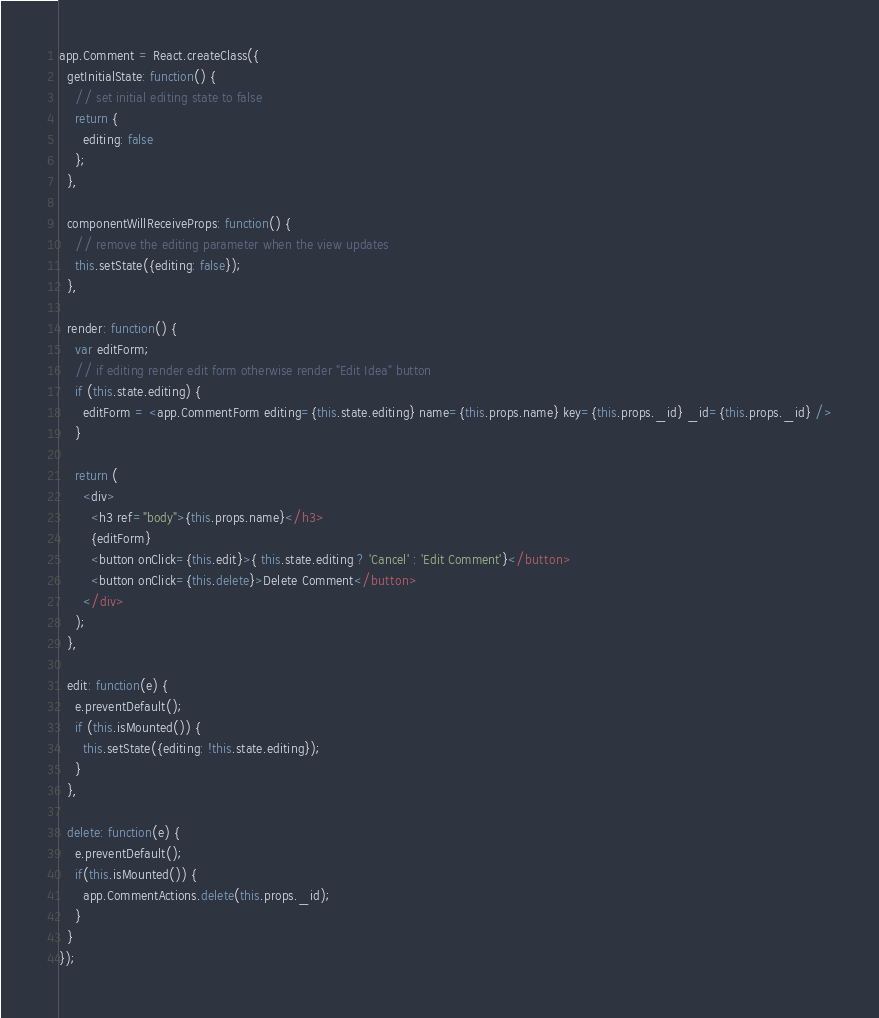<code> <loc_0><loc_0><loc_500><loc_500><_JavaScript_>app.Comment = React.createClass({
  getInitialState: function() {
    // set initial editing state to false
    return {
      editing: false
    };
  },

  componentWillReceiveProps: function() {
    // remove the editing parameter when the view updates
    this.setState({editing: false});
  },

  render: function() {
    var editForm;
    // if editing render edit form otherwise render "Edit Idea" button
    if (this.state.editing) {
      editForm = <app.CommentForm editing={this.state.editing} name={this.props.name} key={this.props._id} _id={this.props._id} />
    }

    return (
      <div>
        <h3 ref="body">{this.props.name}</h3>
        {editForm}
        <button onClick={this.edit}>{ this.state.editing ? 'Cancel' : 'Edit Comment'}</button>
        <button onClick={this.delete}>Delete Comment</button>
      </div>
    );
  },

  edit: function(e) {
    e.preventDefault();
    if (this.isMounted()) {
      this.setState({editing: !this.state.editing});
    }
  },

  delete: function(e) {
    e.preventDefault();
    if(this.isMounted()) {
      app.CommentActions.delete(this.props._id);
    }
  }
});
</code> 